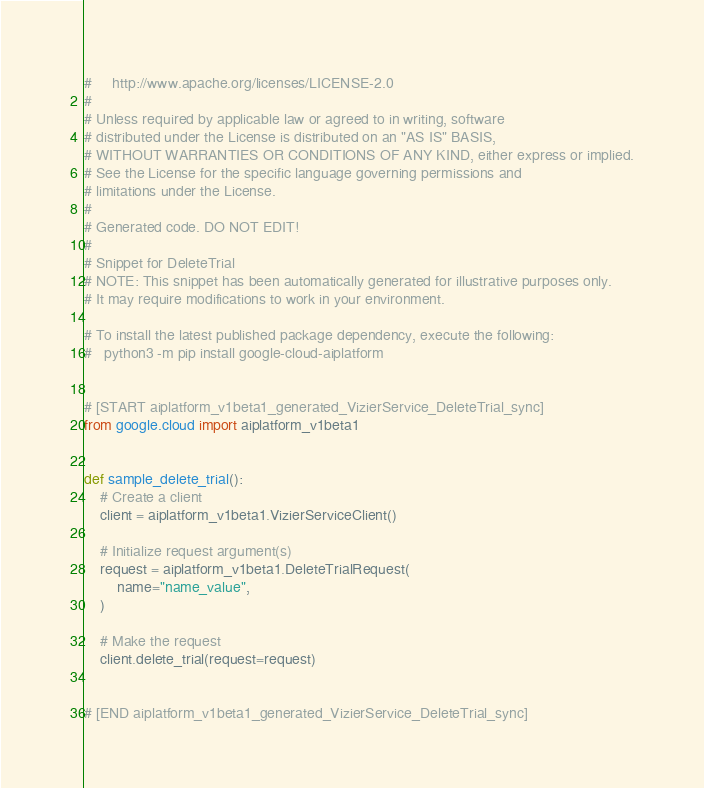<code> <loc_0><loc_0><loc_500><loc_500><_Python_>#     http://www.apache.org/licenses/LICENSE-2.0
#
# Unless required by applicable law or agreed to in writing, software
# distributed under the License is distributed on an "AS IS" BASIS,
# WITHOUT WARRANTIES OR CONDITIONS OF ANY KIND, either express or implied.
# See the License for the specific language governing permissions and
# limitations under the License.
#
# Generated code. DO NOT EDIT!
#
# Snippet for DeleteTrial
# NOTE: This snippet has been automatically generated for illustrative purposes only.
# It may require modifications to work in your environment.

# To install the latest published package dependency, execute the following:
#   python3 -m pip install google-cloud-aiplatform


# [START aiplatform_v1beta1_generated_VizierService_DeleteTrial_sync]
from google.cloud import aiplatform_v1beta1


def sample_delete_trial():
    # Create a client
    client = aiplatform_v1beta1.VizierServiceClient()

    # Initialize request argument(s)
    request = aiplatform_v1beta1.DeleteTrialRequest(
        name="name_value",
    )

    # Make the request
    client.delete_trial(request=request)


# [END aiplatform_v1beta1_generated_VizierService_DeleteTrial_sync]
</code> 